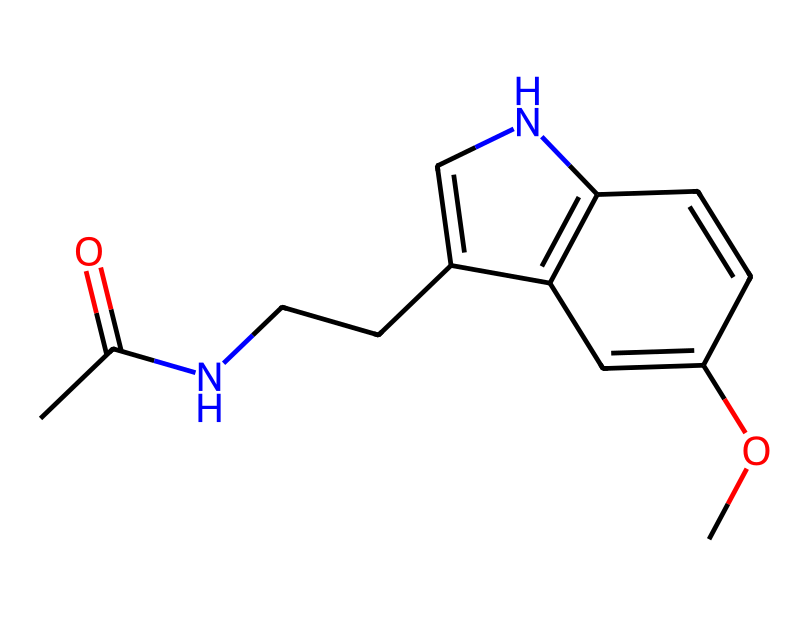What is the molecular formula of melatonin? By analyzing the given SMILES representation, we can count the number of each type of atom present. The molecular structure includes carbon (C), hydrogen (H), nitrogen (N), and oxygen (O) atoms. When counted, the elements correspond to the molecular formula C13H16N2O2.
Answer: C13H16N2O2 How many rings are present in the structure? The SMILES format shows two cycles: one from the cyclized structures (indicating a bicyclic structure with rings) and another nitrogen-containing ring. Thus, there are two distinct rings observed.
Answer: 2 What type of compound is melatonin classified as? Melatonin has a distinct structure that indicates it is classified as an indoleamine, due to the indole ring system and the amine functional group. This classification relates to its biochemical role and structure.
Answer: indoleamine How many nitrogen atoms are in the molecular structure? From examining the given SMILES representation, we can identify the presence of two nitrogen atoms within the structure. They are visible in the nitrogen-containing rings and functional groups.
Answer: 2 What functional groups are present in melatonin? The structure contains an acetyl group (from the acetylation) and an amine group, crucial for its biological activity and function. These functional groups can be identified from the arrangement of atoms in the chemical structure.
Answer: acetyl and amine 